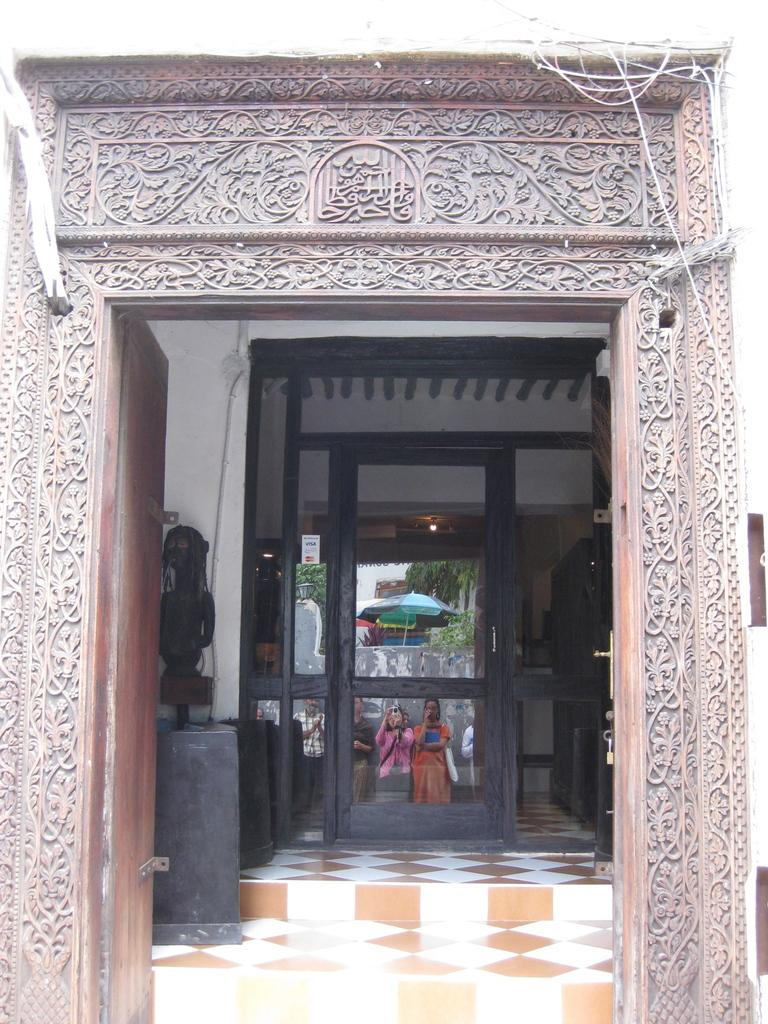What type of structure is depicted in the image? The image appears to be an entry of a building. What are the main features of the building's entry? There are doors in the image. Are there any people present in the image? Yes, there are people standing in the image. What can be seen in the background of the image? There is a wall, an umbrella, and trees visible in the background of the image. What type of coat is the sheep wearing in the image? There is no sheep present in the image, and therefore no coat can be observed. 